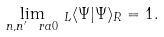Convert formula to latex. <formula><loc_0><loc_0><loc_500><loc_500>\lim _ { n , n ^ { \prime } \ r a 0 } \, _ { L } \langle \Psi | \Psi \rangle _ { R } = 1 .</formula> 